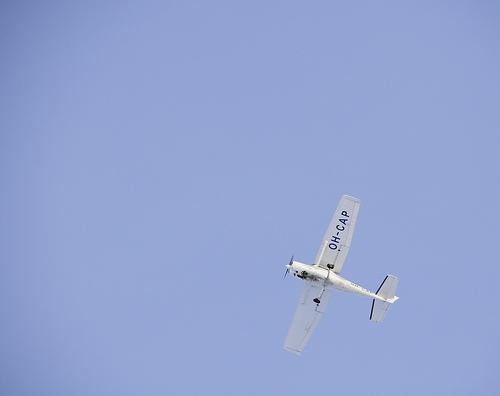Justify the presence of a propeller and its current state in the image. The airplane has a blue propeller, which is turning, indicating that the engine is running and providing thrust for the plane to fly. Mention any distinguishing features of the airplane in the image. The airplane has a blue propeller, blue letters on its wing, a blue stripe on its tail, and two wheels. What is written on the plane's wing and what color is it? 'ohcap' is written in blue on the plane's wing. Count the number of white clouds in the blue sky. There are nine white clouds in the blue sky. What is the color of the sky in this image? The sky is clear blue. Evaluate the image's aesthetic quality, considering composition and color. The image has a pleasing aesthetic quality with a harmonious color palette of blue and white and a balanced composition featuring an airplane in the sky. What is the primary action the plane is performing in this image? The plane is flying in the air. Provide a brief description of the primary object in the image. A small white plane with a blue propeller and blue letters on its wing is flying in a clear blue sky. Analyze the sentiment that this image might evoke in a viewer. The image evokes a feeling of calmness and freedom as a small plane is flying in a clear blue sky. How many wheels are visible on the airplane in the image? Two wheels are visible on the airplane. Do the propellers of the plane have green tips? No, it's not mentioned in the image. Can you see a large commercial airliner in the image? The image contains only a small white plane, which is not a large commercial airliner. 